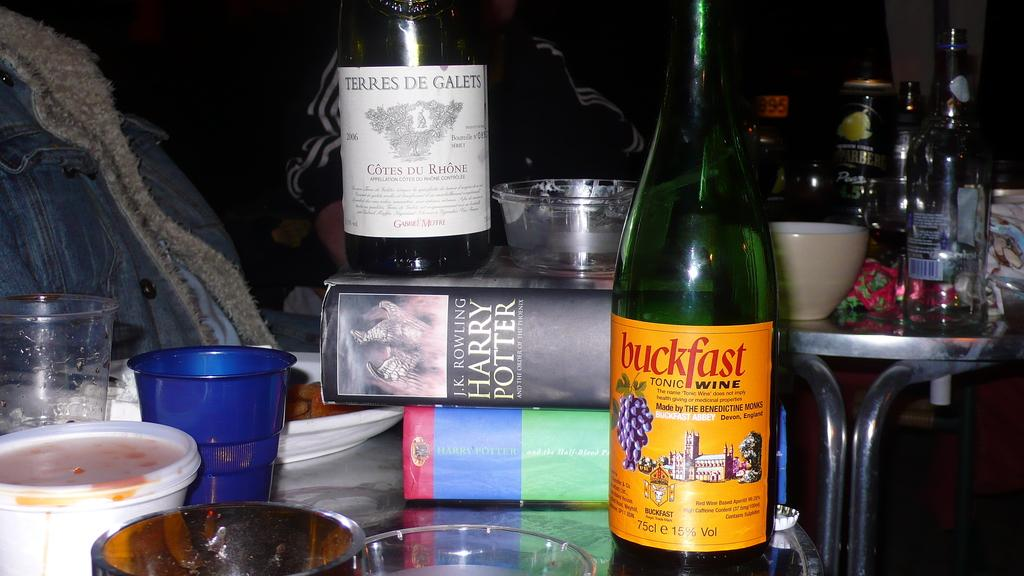<image>
Provide a brief description of the given image. A bottle of buckfast tonic wine has a yellow label with purple grapes on it. 